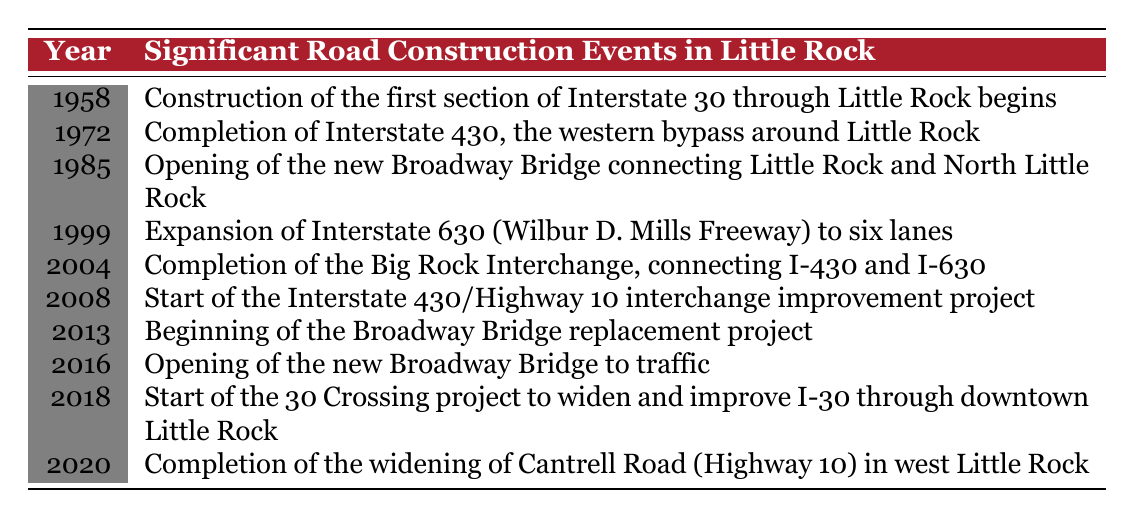What year did the construction of Interstate 30 in Little Rock begin? The table indicates that the construction of the first section of Interstate 30 through Little Rock began in the year 1958.
Answer: 1958 What significant road construction event happened in 2004? According to the table, in 2004, the completion of the Big Rock Interchange, which connects I-430 and I-630, was the significant event.
Answer: Completion of the Big Rock Interchange Were there any significant road construction events in Little Rock during the 1990s? The table shows that there was one significant event in the 1990s, which is the expansion of Interstate 630 to six lanes. Therefore, the answer is yes.
Answer: Yes How many years passed between the opening of the new Broadway Bridge and its replacement project? The opening of the new Broadway Bridge was in 1985, and the beginning of its replacement project was in 2013. The difference in years is 2013 - 1985 = 28 years.
Answer: 28 years What is the latest significant road construction project listed in the table? The table indicates that the most recent event is the completion of the widening of Cantrell Road in 2020, which signifies the latest significant road construction project.
Answer: Completion of the widening of Cantrell Road Was the expansion of Interstate 630 completed before the opening of the new Broadway Bridge? To answer this, review the years: Interstate 630 expansion was in 1999 and the Broadway Bridge opened in 1985. Since 1999 is later than 1985, the answer is no.
Answer: No How many significant road construction projects started after 2010? Looking through the table, the projects that started after 2010 are: the Interstate 430/Highway 10 interchange project in 2008 and the 30 Crossing project in 2018. So, from 2013 onward, there are two projects: the Broadway Bridge replacement in 2013 and the 30 Crossing in 2018. Thus, there are 2 projects after 2010.
Answer: 2 projects What percentage of the events listed involve bridges? The events involving bridges are the opening of the new Broadway Bridge (1985) and the replacement project (2013). There are 2 out of 10 events listed, so the percentage is (2/10) * 100 = 20%.
Answer: 20% What is the total span of years covered by the events listed in the table? The first event occurred in 1958 and the last event in 2020. Therefore, the total span in years is 2020 - 1958 = 62 years.
Answer: 62 years 